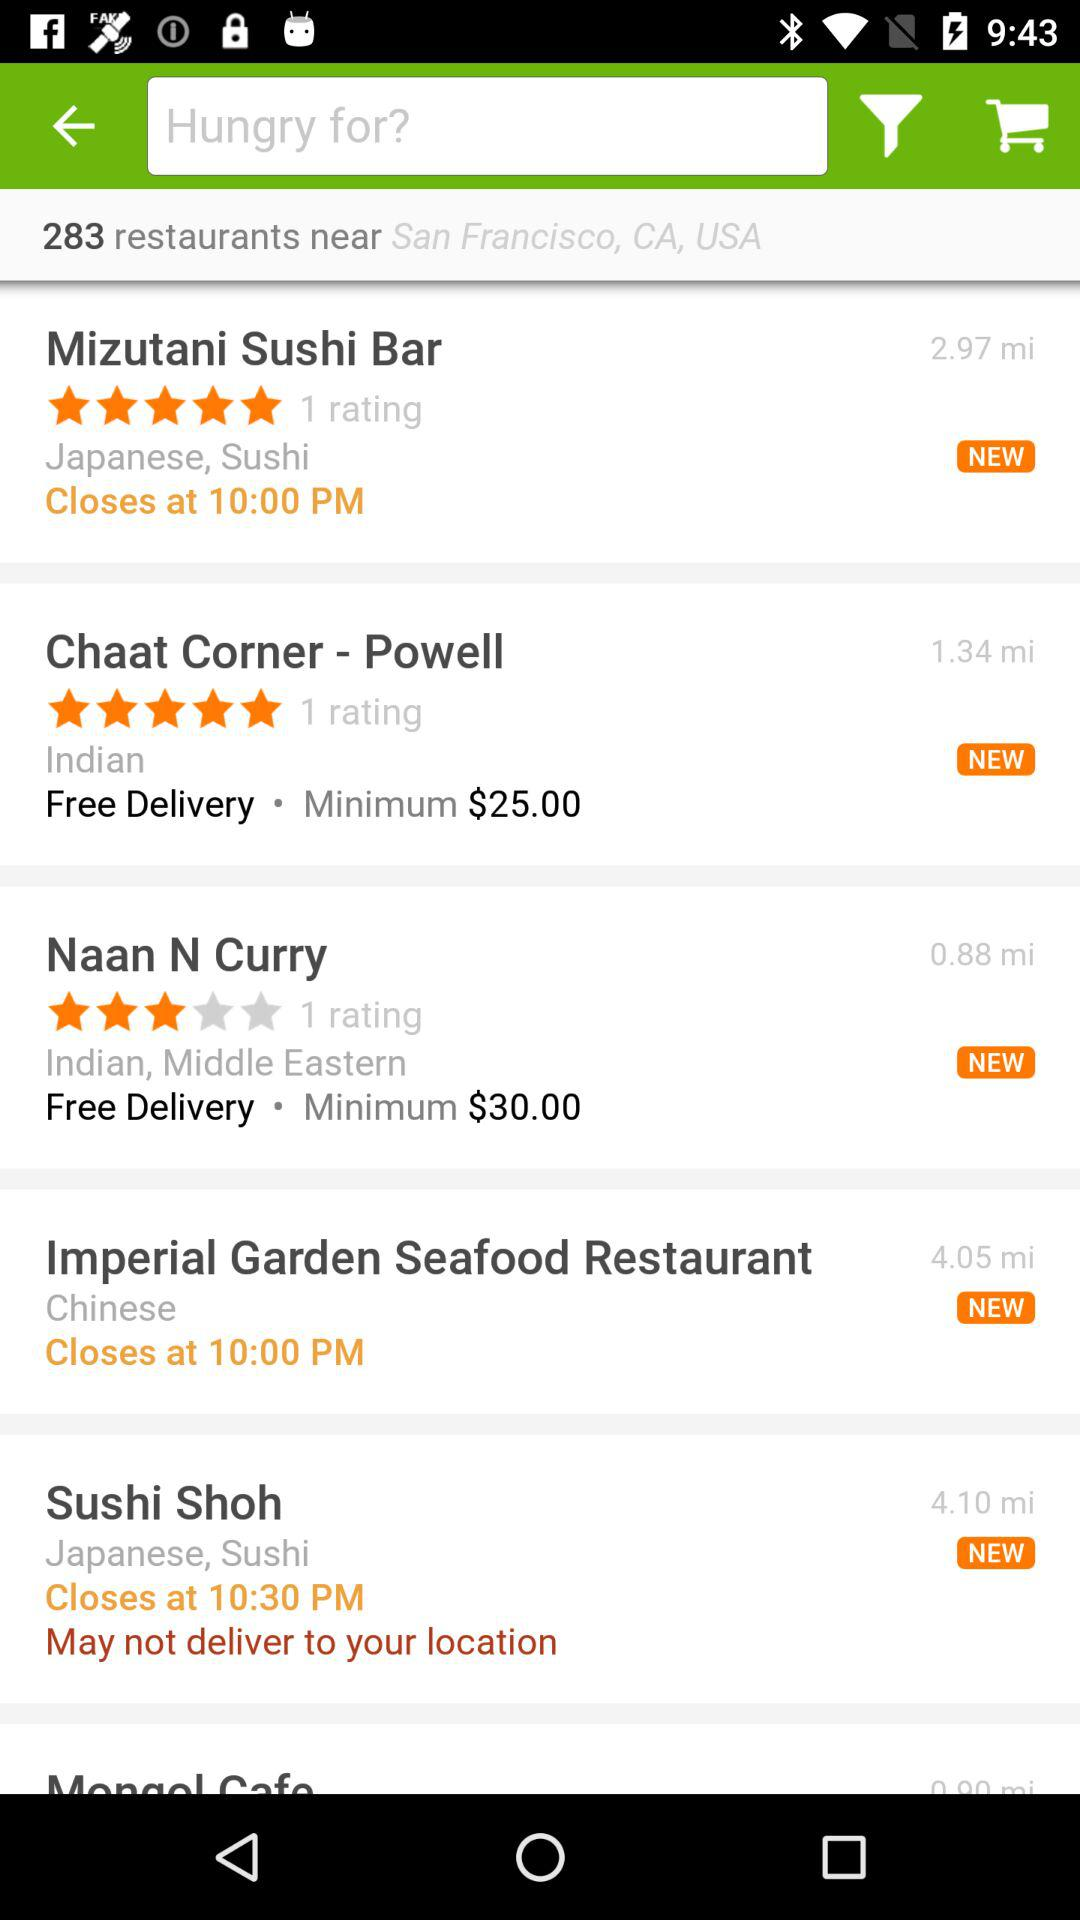What type of restaurant is "Chaat Corner"? The type of restaurant is "Indian". 